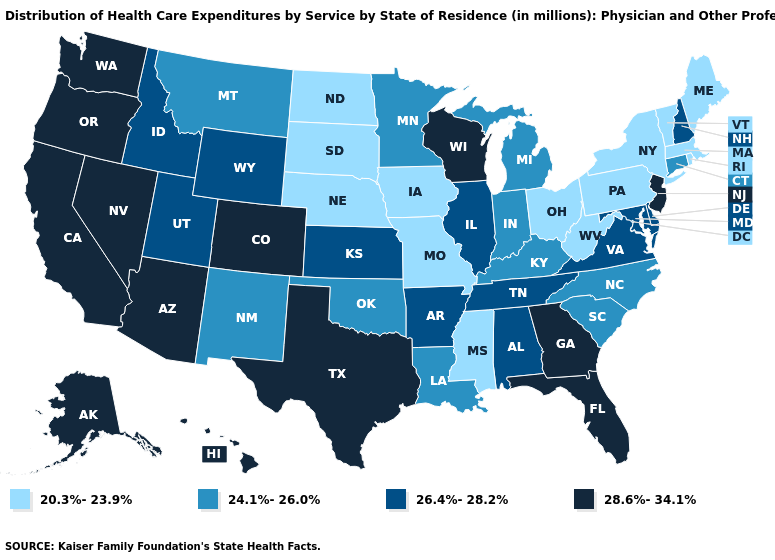What is the value of Utah?
Short answer required. 26.4%-28.2%. Is the legend a continuous bar?
Write a very short answer. No. Does Nevada have the same value as Alaska?
Give a very brief answer. Yes. What is the lowest value in the West?
Be succinct. 24.1%-26.0%. Name the states that have a value in the range 26.4%-28.2%?
Keep it brief. Alabama, Arkansas, Delaware, Idaho, Illinois, Kansas, Maryland, New Hampshire, Tennessee, Utah, Virginia, Wyoming. What is the lowest value in the MidWest?
Write a very short answer. 20.3%-23.9%. Among the states that border Idaho , does Oregon have the highest value?
Be succinct. Yes. Does the map have missing data?
Answer briefly. No. Name the states that have a value in the range 20.3%-23.9%?
Concise answer only. Iowa, Maine, Massachusetts, Mississippi, Missouri, Nebraska, New York, North Dakota, Ohio, Pennsylvania, Rhode Island, South Dakota, Vermont, West Virginia. Name the states that have a value in the range 28.6%-34.1%?
Answer briefly. Alaska, Arizona, California, Colorado, Florida, Georgia, Hawaii, Nevada, New Jersey, Oregon, Texas, Washington, Wisconsin. Does Texas have the highest value in the South?
Keep it brief. Yes. Name the states that have a value in the range 26.4%-28.2%?
Be succinct. Alabama, Arkansas, Delaware, Idaho, Illinois, Kansas, Maryland, New Hampshire, Tennessee, Utah, Virginia, Wyoming. Does Mississippi have the lowest value in the USA?
Short answer required. Yes. Which states have the lowest value in the USA?
Write a very short answer. Iowa, Maine, Massachusetts, Mississippi, Missouri, Nebraska, New York, North Dakota, Ohio, Pennsylvania, Rhode Island, South Dakota, Vermont, West Virginia. 